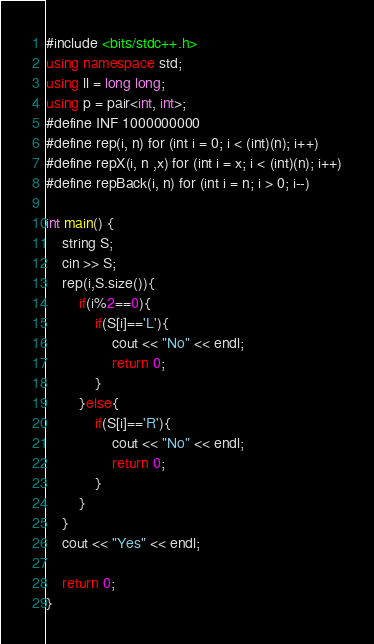<code> <loc_0><loc_0><loc_500><loc_500><_C++_>#include <bits/stdc++.h>
using namespace std;
using ll = long long;
using p = pair<int, int>;
#define INF 1000000000
#define rep(i, n) for (int i = 0; i < (int)(n); i++)
#define repX(i, n ,x) for (int i = x; i < (int)(n); i++)
#define repBack(i, n) for (int i = n; i > 0; i--)

int main() {
    string S;
    cin >> S;
    rep(i,S.size()){
        if(i%2==0){
            if(S[i]=='L'){
                cout << "No" << endl;
                return 0;
            }
        }else{
            if(S[i]=='R'){
                cout << "No" << endl;
                return 0;
            }
        }
    }
    cout << "Yes" << endl;

    return 0;
}</code> 